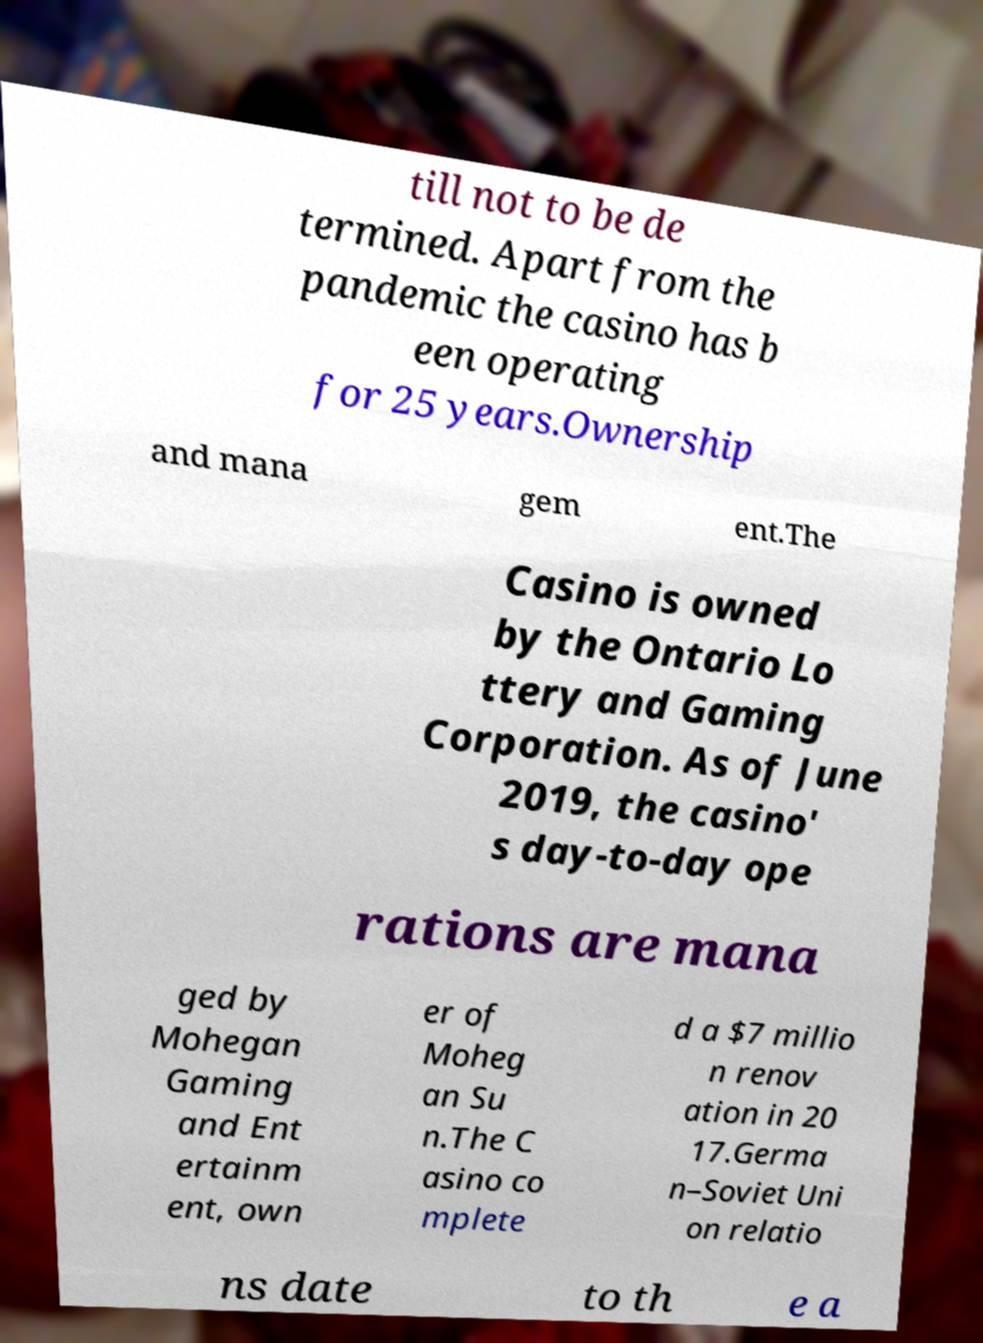Can you accurately transcribe the text from the provided image for me? till not to be de termined. Apart from the pandemic the casino has b een operating for 25 years.Ownership and mana gem ent.The Casino is owned by the Ontario Lo ttery and Gaming Corporation. As of June 2019, the casino' s day-to-day ope rations are mana ged by Mohegan Gaming and Ent ertainm ent, own er of Moheg an Su n.The C asino co mplete d a $7 millio n renov ation in 20 17.Germa n–Soviet Uni on relatio ns date to th e a 